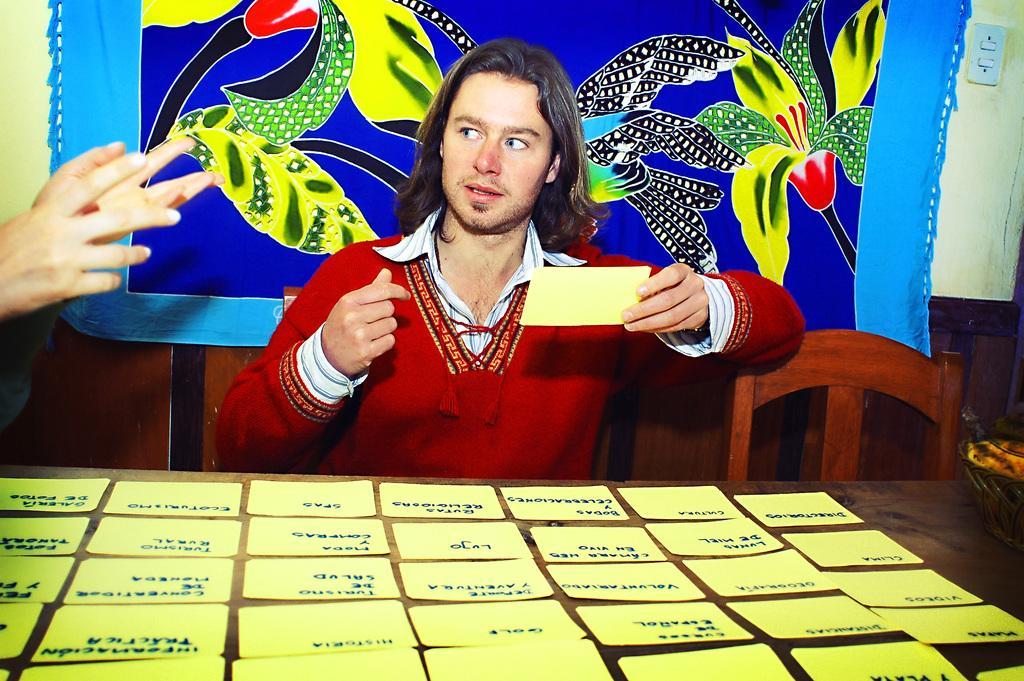Can you describe this image briefly? On the background of the picture we can see a wall and this is a bed sheet. Here we can see one man sitting and staring at some other person and he is holding a yellow color paper in his hand and on the table we can see some papers and there is something written on it. 